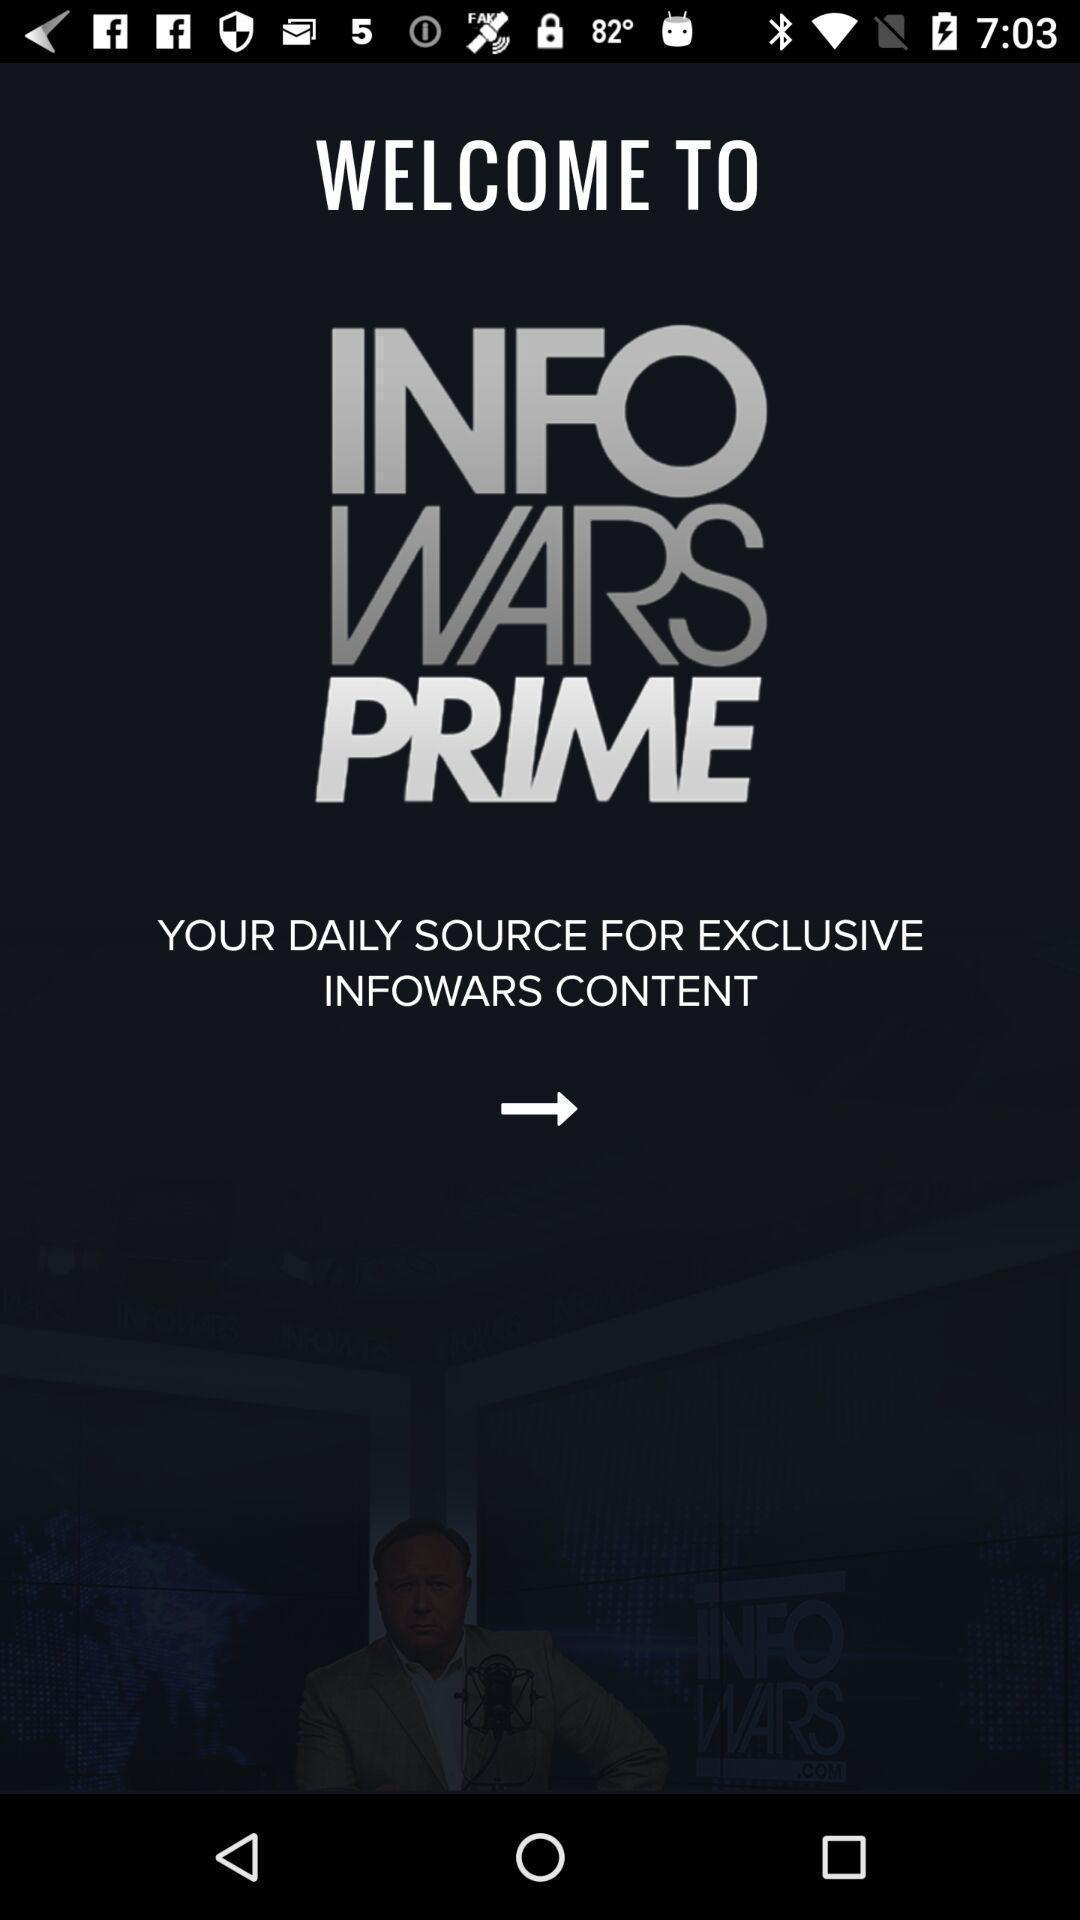Describe this image in words. Welcome page to the application. 